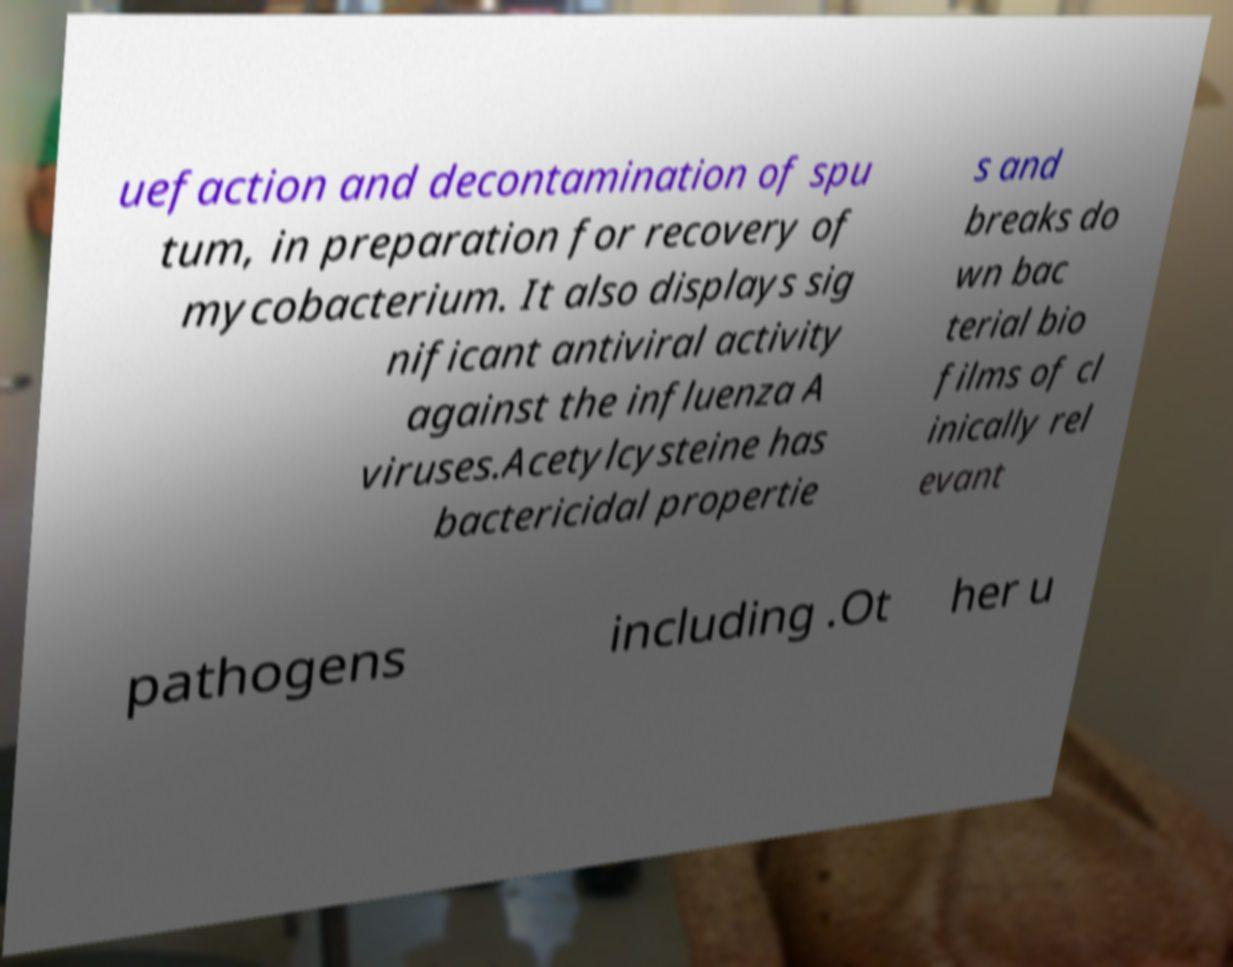There's text embedded in this image that I need extracted. Can you transcribe it verbatim? uefaction and decontamination of spu tum, in preparation for recovery of mycobacterium. It also displays sig nificant antiviral activity against the influenza A viruses.Acetylcysteine has bactericidal propertie s and breaks do wn bac terial bio films of cl inically rel evant pathogens including .Ot her u 